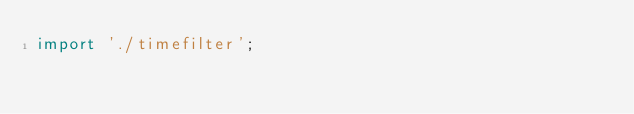<code> <loc_0><loc_0><loc_500><loc_500><_JavaScript_>import './timefilter';
</code> 